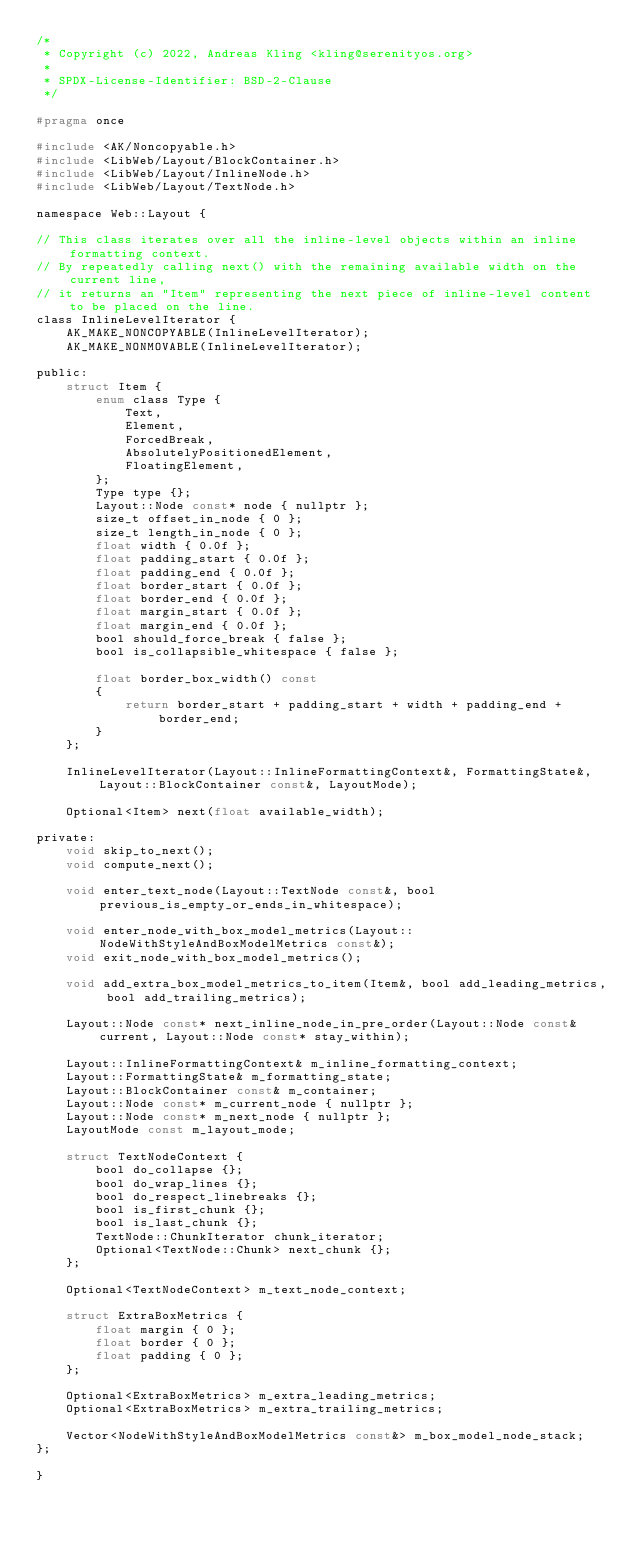Convert code to text. <code><loc_0><loc_0><loc_500><loc_500><_C_>/*
 * Copyright (c) 2022, Andreas Kling <kling@serenityos.org>
 *
 * SPDX-License-Identifier: BSD-2-Clause
 */

#pragma once

#include <AK/Noncopyable.h>
#include <LibWeb/Layout/BlockContainer.h>
#include <LibWeb/Layout/InlineNode.h>
#include <LibWeb/Layout/TextNode.h>

namespace Web::Layout {

// This class iterates over all the inline-level objects within an inline formatting context.
// By repeatedly calling next() with the remaining available width on the current line,
// it returns an "Item" representing the next piece of inline-level content to be placed on the line.
class InlineLevelIterator {
    AK_MAKE_NONCOPYABLE(InlineLevelIterator);
    AK_MAKE_NONMOVABLE(InlineLevelIterator);

public:
    struct Item {
        enum class Type {
            Text,
            Element,
            ForcedBreak,
            AbsolutelyPositionedElement,
            FloatingElement,
        };
        Type type {};
        Layout::Node const* node { nullptr };
        size_t offset_in_node { 0 };
        size_t length_in_node { 0 };
        float width { 0.0f };
        float padding_start { 0.0f };
        float padding_end { 0.0f };
        float border_start { 0.0f };
        float border_end { 0.0f };
        float margin_start { 0.0f };
        float margin_end { 0.0f };
        bool should_force_break { false };
        bool is_collapsible_whitespace { false };

        float border_box_width() const
        {
            return border_start + padding_start + width + padding_end + border_end;
        }
    };

    InlineLevelIterator(Layout::InlineFormattingContext&, FormattingState&, Layout::BlockContainer const&, LayoutMode);

    Optional<Item> next(float available_width);

private:
    void skip_to_next();
    void compute_next();

    void enter_text_node(Layout::TextNode const&, bool previous_is_empty_or_ends_in_whitespace);

    void enter_node_with_box_model_metrics(Layout::NodeWithStyleAndBoxModelMetrics const&);
    void exit_node_with_box_model_metrics();

    void add_extra_box_model_metrics_to_item(Item&, bool add_leading_metrics, bool add_trailing_metrics);

    Layout::Node const* next_inline_node_in_pre_order(Layout::Node const& current, Layout::Node const* stay_within);

    Layout::InlineFormattingContext& m_inline_formatting_context;
    Layout::FormattingState& m_formatting_state;
    Layout::BlockContainer const& m_container;
    Layout::Node const* m_current_node { nullptr };
    Layout::Node const* m_next_node { nullptr };
    LayoutMode const m_layout_mode;

    struct TextNodeContext {
        bool do_collapse {};
        bool do_wrap_lines {};
        bool do_respect_linebreaks {};
        bool is_first_chunk {};
        bool is_last_chunk {};
        TextNode::ChunkIterator chunk_iterator;
        Optional<TextNode::Chunk> next_chunk {};
    };

    Optional<TextNodeContext> m_text_node_context;

    struct ExtraBoxMetrics {
        float margin { 0 };
        float border { 0 };
        float padding { 0 };
    };

    Optional<ExtraBoxMetrics> m_extra_leading_metrics;
    Optional<ExtraBoxMetrics> m_extra_trailing_metrics;

    Vector<NodeWithStyleAndBoxModelMetrics const&> m_box_model_node_stack;
};

}
</code> 